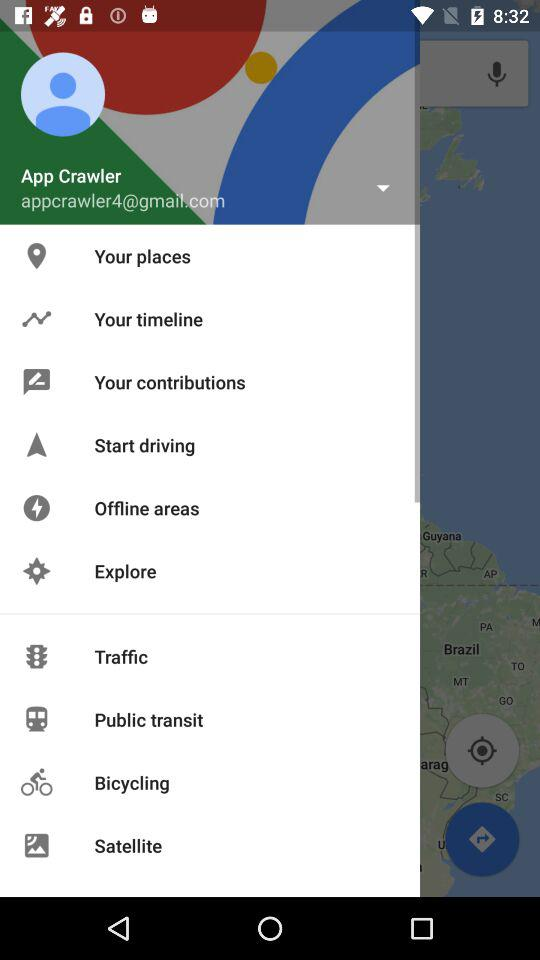What is the email address? The email address is appcrawler4@gmail.com. 